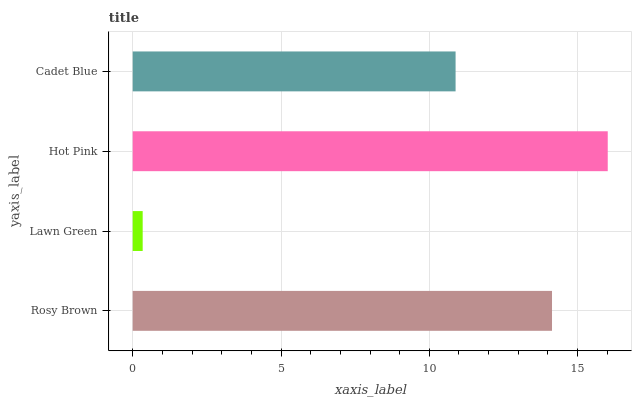Is Lawn Green the minimum?
Answer yes or no. Yes. Is Hot Pink the maximum?
Answer yes or no. Yes. Is Hot Pink the minimum?
Answer yes or no. No. Is Lawn Green the maximum?
Answer yes or no. No. Is Hot Pink greater than Lawn Green?
Answer yes or no. Yes. Is Lawn Green less than Hot Pink?
Answer yes or no. Yes. Is Lawn Green greater than Hot Pink?
Answer yes or no. No. Is Hot Pink less than Lawn Green?
Answer yes or no. No. Is Rosy Brown the high median?
Answer yes or no. Yes. Is Cadet Blue the low median?
Answer yes or no. Yes. Is Lawn Green the high median?
Answer yes or no. No. Is Rosy Brown the low median?
Answer yes or no. No. 